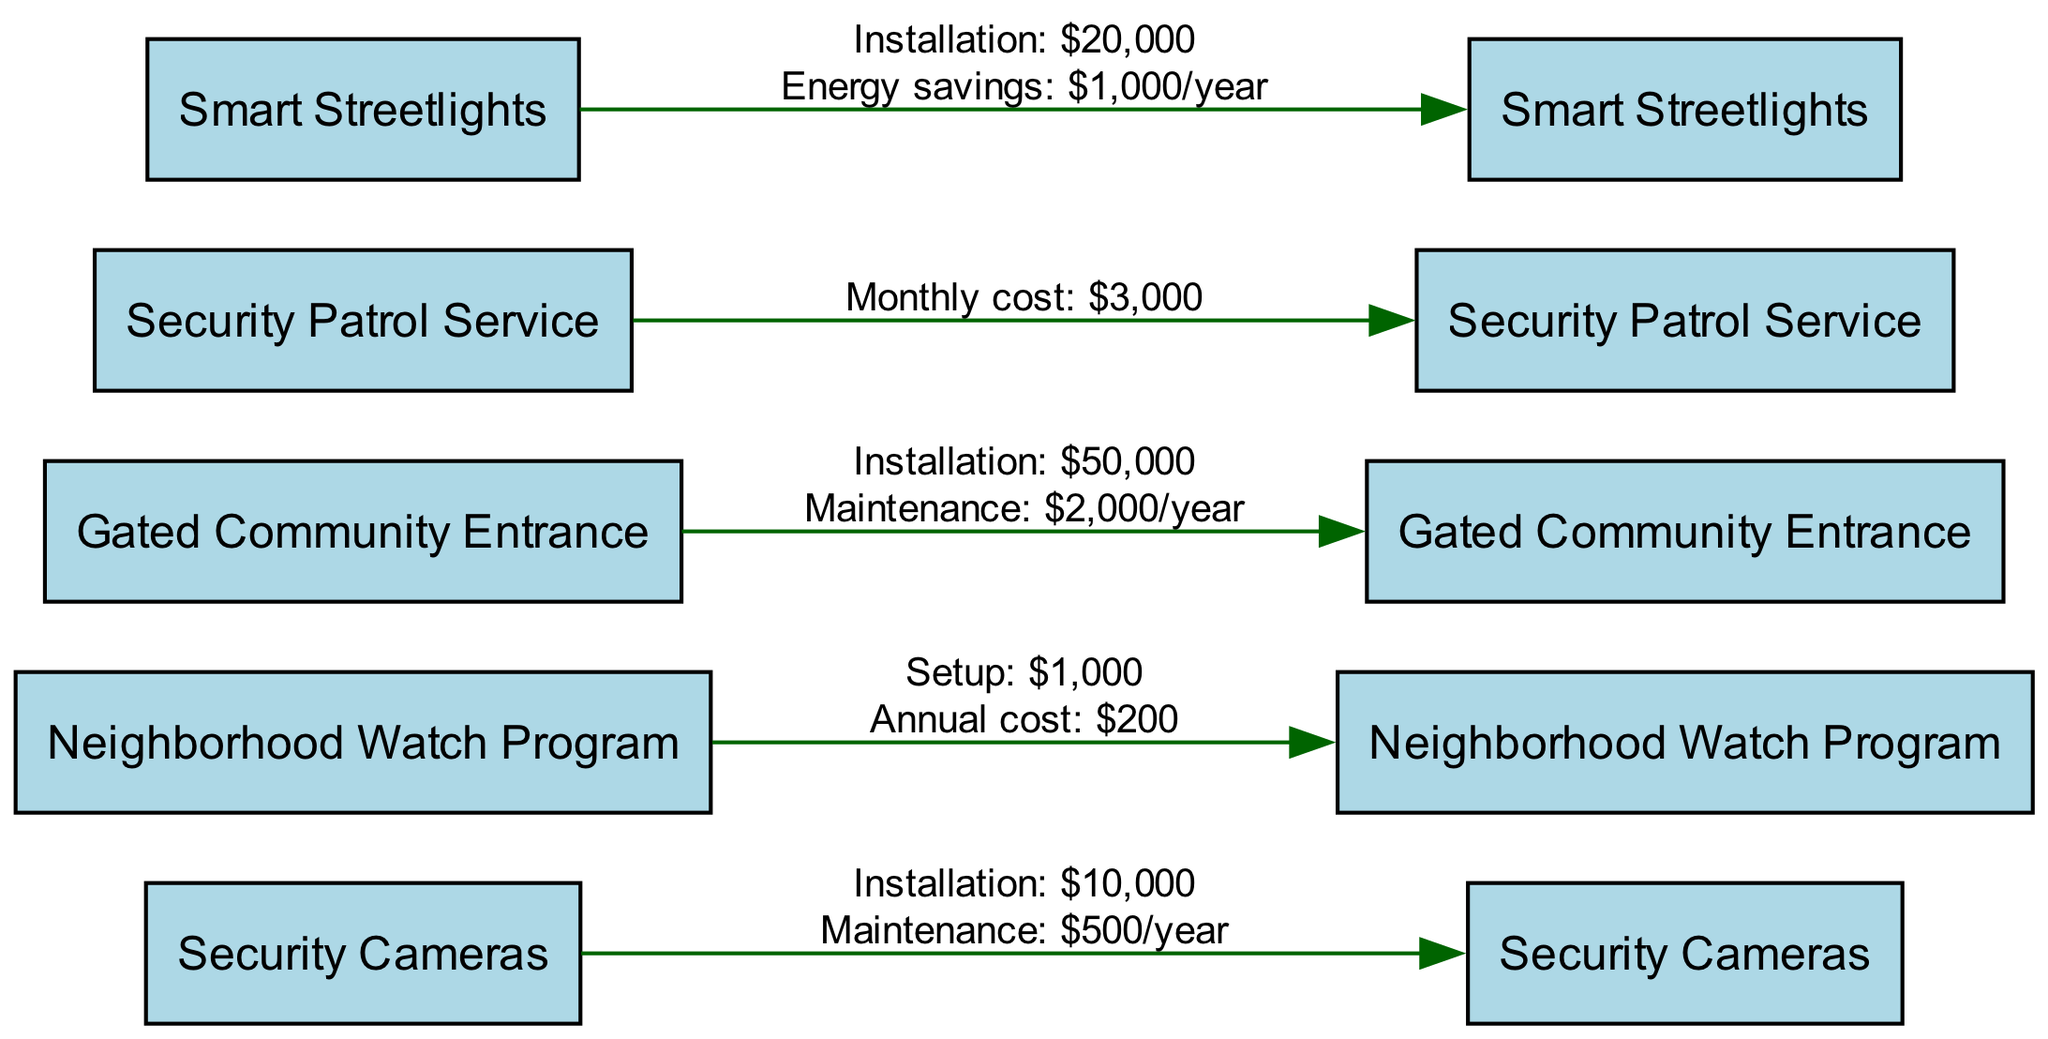What is the installation cost of the Security Cameras? The diagram indicates that the installation cost of Security Cameras is listed as $10,000.
Answer: $10,000 What is the annual cost of the Neighborhood Watch Program? The diagram shows that the annual cost associated with the Neighborhood Watch Program is $200.
Answer: $200 How many security measures are proposed in the diagram? The diagram includes a total of five nodes representing different security measures: Security Cameras, Neighborhood Watch Program, Gated Community Entrance, Security Patrol Service, and Smart Streetlights.
Answer: 5 What is the monthly cost of the Security Patrol Service? Based on the diagram, the Security Patrol Service has a monthly cost of $3,000 listed.
Answer: $3,000 What is the maintenance cost for the Gated Community Entrance? The diagram clearly states that the maintenance cost for the Gated Community Entrance is $2,000 per year.
Answer: $2,000 Which security measure has the highest installation cost? Reviewing the installation costs in the diagram, the Gated Community Entrance at $50,000 has the highest installation cost among all proposed measures.
Answer: Gated Community Entrance What is the energy savings per year from installing Smart Streetlights? The diagram specifies that the Smart Streetlights generate energy savings of $1,000 per year due to their installation.
Answer: $1,000 Which security measure has an annual maintenance cost? The diagram reveals that both Security Cameras and the Gated Community Entrance have annual maintenance costs specified.
Answer: Security Cameras, Gated Community Entrance What is the total cost of installation and first-year maintenance for Security Cameras? To answer, we add the installation cost of Security Cameras ($10,000) to the first-year maintenance cost ($500), giving a total of $10,500 for the first year.
Answer: $10,500 What is the total first-year cost of the Neighborhood Watch Program? The first-year cost consists of the initial setup cost of $1,000 plus the annual cost of $200, resulting in a total first-year cost of $1,200 for the Neighborhood Watch Program.
Answer: $1,200 